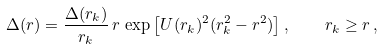<formula> <loc_0><loc_0><loc_500><loc_500>\Delta ( r ) = \frac { \Delta ( r _ { k } ) } { r _ { k } } \, r \, \exp \left [ U ( r _ { k } ) ^ { 2 } ( r ^ { 2 } _ { k } - r ^ { 2 } ) \right ] , \quad r _ { k } \geq r \, ,</formula> 